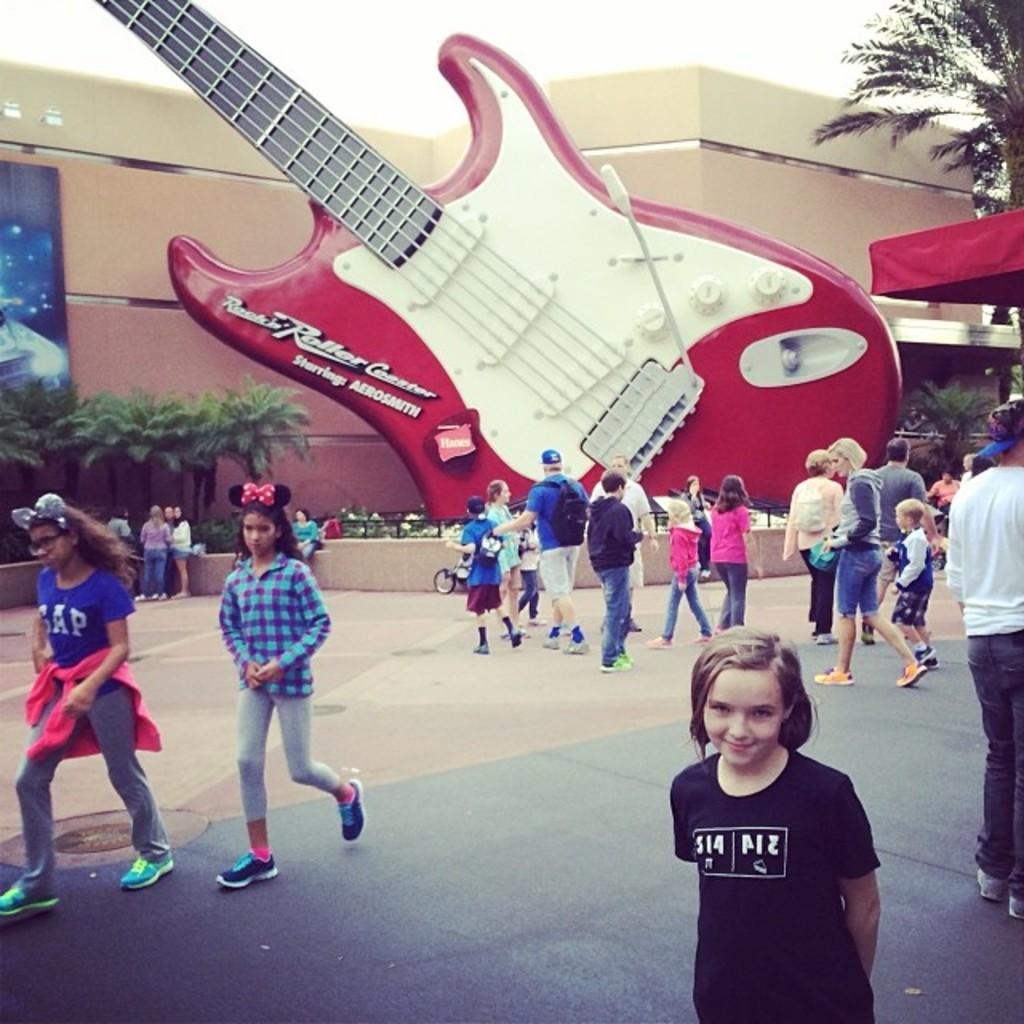Can you describe this image briefly? In this image there are few people walking on the floor. In the background there is a guitar statue. Behind the statue there is a building. On the left side there are trees. There is a banner which is attached to the wall. 